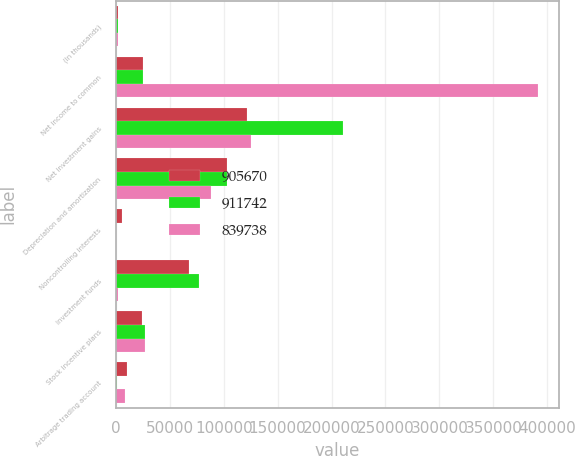Convert chart. <chart><loc_0><loc_0><loc_500><loc_500><stacked_bar_chart><ecel><fcel>(In thousands)<fcel>Net income to common<fcel>Net investment gains<fcel>Depreciation and amortization<fcel>Noncontrolling interests<fcel>Investment funds<fcel>Stock incentive plans<fcel>Arbitrage trading account<nl><fcel>905670<fcel>2013<fcel>25273.5<fcel>121544<fcel>103090<fcel>5376<fcel>67712<fcel>23784<fcel>10324<nl><fcel>911742<fcel>2012<fcel>25273.5<fcel>210465<fcel>103419<fcel>51<fcel>77015<fcel>26763<fcel>1424<nl><fcel>839738<fcel>2011<fcel>391211<fcel>125481<fcel>88012<fcel>70<fcel>1751<fcel>27175<fcel>8106<nl></chart> 